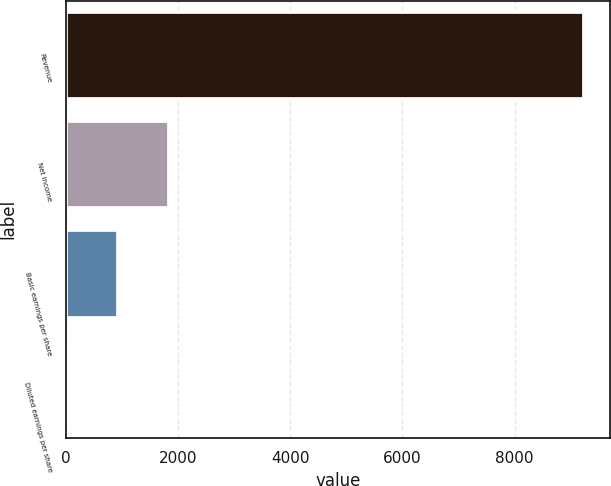Convert chart. <chart><loc_0><loc_0><loc_500><loc_500><bar_chart><fcel>Revenue<fcel>Net income<fcel>Basic earnings per share<fcel>Diluted earnings per share<nl><fcel>9244.9<fcel>1849.85<fcel>925.47<fcel>1.09<nl></chart> 